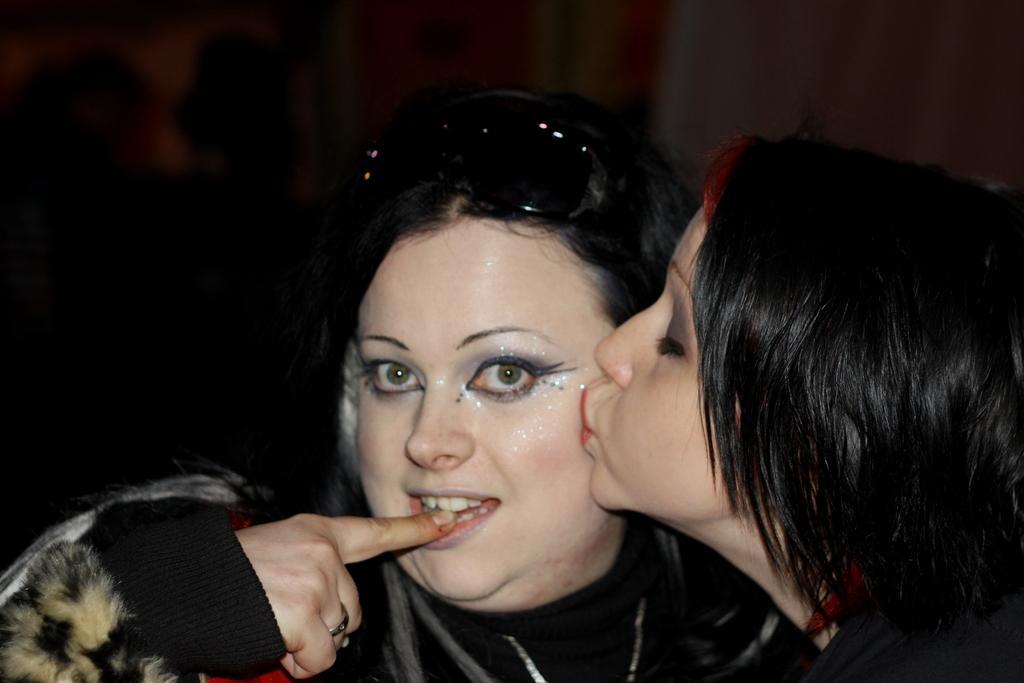How would you summarize this image in a sentence or two? In this picture we can see one girl is kissing to the woman. 